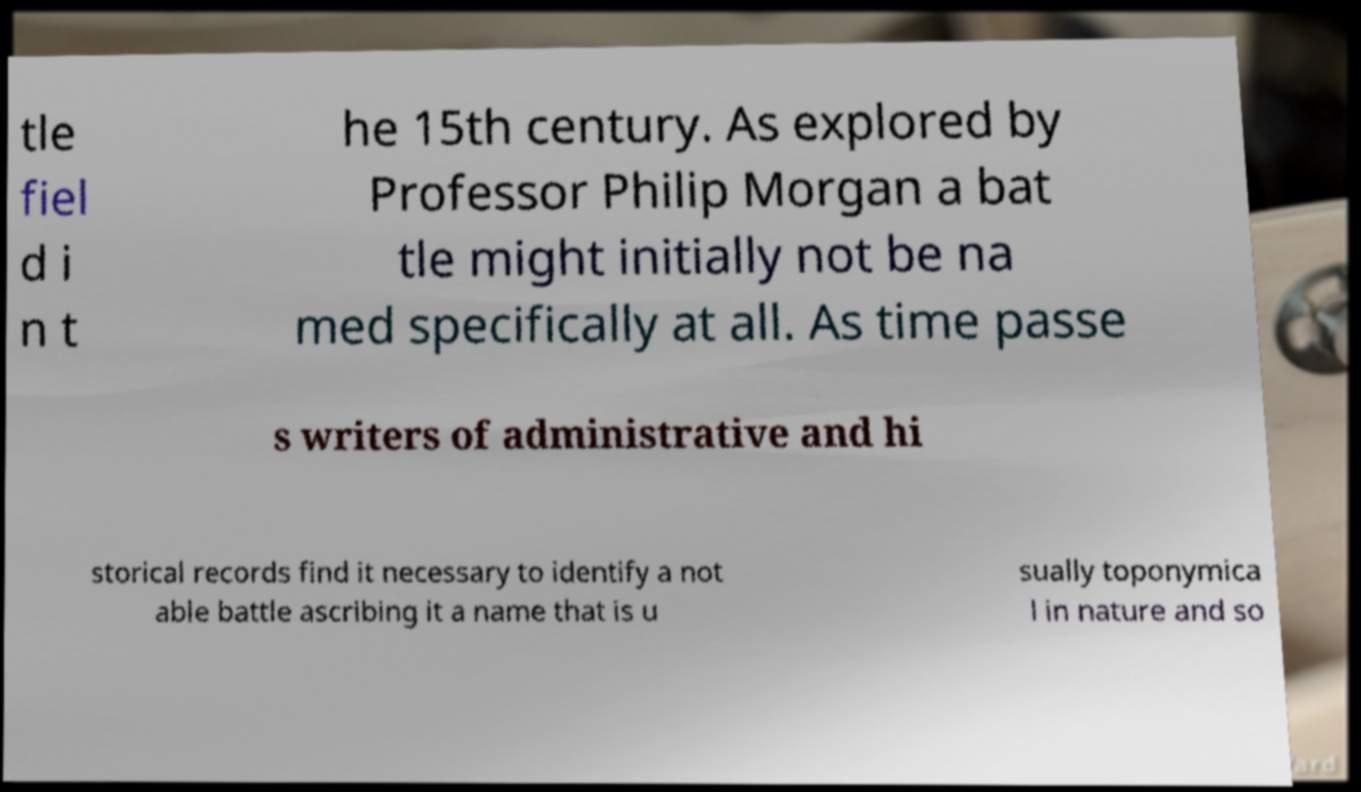Can you read and provide the text displayed in the image?This photo seems to have some interesting text. Can you extract and type it out for me? tle fiel d i n t he 15th century. As explored by Professor Philip Morgan a bat tle might initially not be na med specifically at all. As time passe s writers of administrative and hi storical records find it necessary to identify a not able battle ascribing it a name that is u sually toponymica l in nature and so 